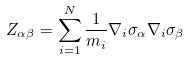Convert formula to latex. <formula><loc_0><loc_0><loc_500><loc_500>Z _ { \alpha \beta } = \sum _ { i = 1 } ^ { N } \frac { 1 } { m _ { i } } \nabla _ { i } \sigma _ { \alpha } \nabla _ { i } \sigma _ { \beta }</formula> 